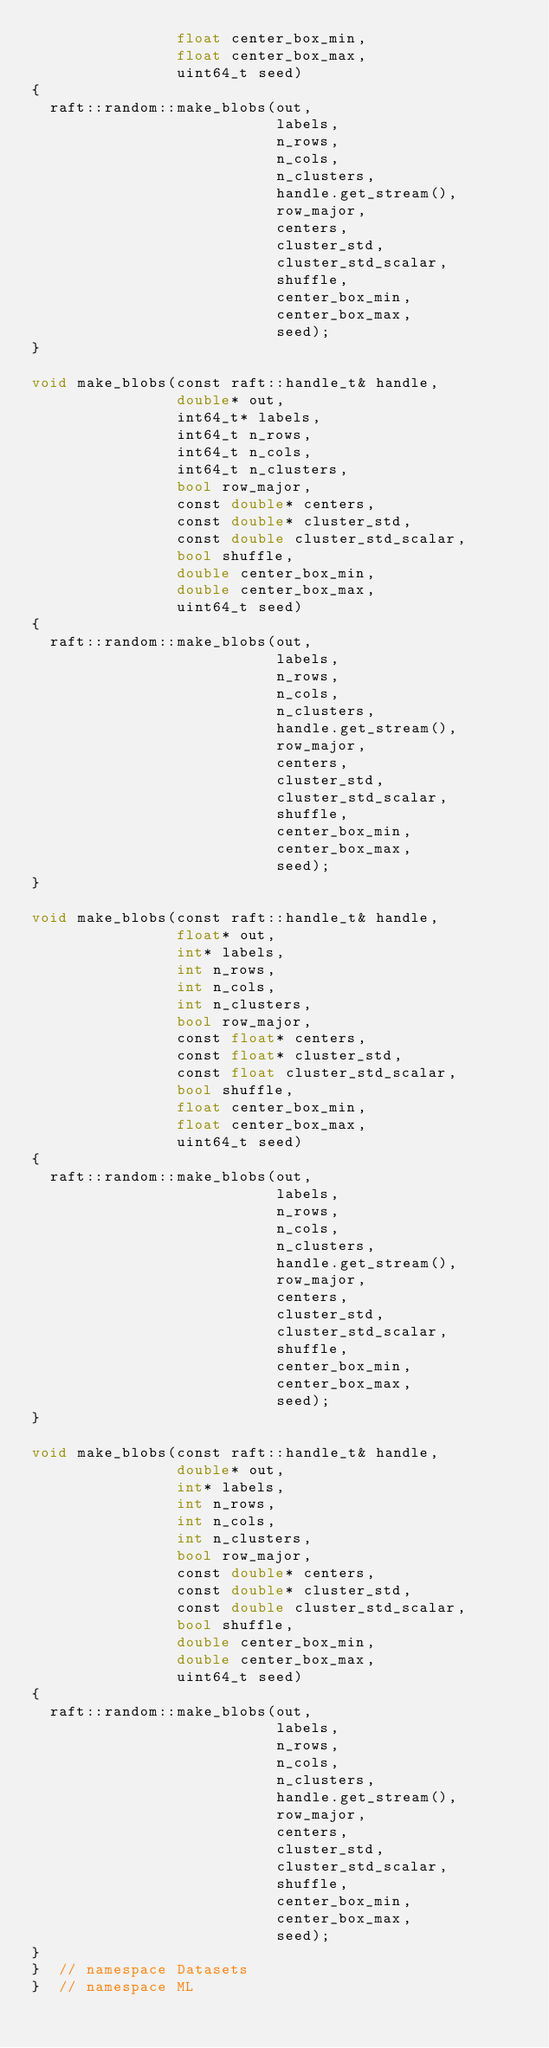<code> <loc_0><loc_0><loc_500><loc_500><_Cuda_>                float center_box_min,
                float center_box_max,
                uint64_t seed)
{
  raft::random::make_blobs(out,
                           labels,
                           n_rows,
                           n_cols,
                           n_clusters,
                           handle.get_stream(),
                           row_major,
                           centers,
                           cluster_std,
                           cluster_std_scalar,
                           shuffle,
                           center_box_min,
                           center_box_max,
                           seed);
}

void make_blobs(const raft::handle_t& handle,
                double* out,
                int64_t* labels,
                int64_t n_rows,
                int64_t n_cols,
                int64_t n_clusters,
                bool row_major,
                const double* centers,
                const double* cluster_std,
                const double cluster_std_scalar,
                bool shuffle,
                double center_box_min,
                double center_box_max,
                uint64_t seed)
{
  raft::random::make_blobs(out,
                           labels,
                           n_rows,
                           n_cols,
                           n_clusters,
                           handle.get_stream(),
                           row_major,
                           centers,
                           cluster_std,
                           cluster_std_scalar,
                           shuffle,
                           center_box_min,
                           center_box_max,
                           seed);
}

void make_blobs(const raft::handle_t& handle,
                float* out,
                int* labels,
                int n_rows,
                int n_cols,
                int n_clusters,
                bool row_major,
                const float* centers,
                const float* cluster_std,
                const float cluster_std_scalar,
                bool shuffle,
                float center_box_min,
                float center_box_max,
                uint64_t seed)
{
  raft::random::make_blobs(out,
                           labels,
                           n_rows,
                           n_cols,
                           n_clusters,
                           handle.get_stream(),
                           row_major,
                           centers,
                           cluster_std,
                           cluster_std_scalar,
                           shuffle,
                           center_box_min,
                           center_box_max,
                           seed);
}

void make_blobs(const raft::handle_t& handle,
                double* out,
                int* labels,
                int n_rows,
                int n_cols,
                int n_clusters,
                bool row_major,
                const double* centers,
                const double* cluster_std,
                const double cluster_std_scalar,
                bool shuffle,
                double center_box_min,
                double center_box_max,
                uint64_t seed)
{
  raft::random::make_blobs(out,
                           labels,
                           n_rows,
                           n_cols,
                           n_clusters,
                           handle.get_stream(),
                           row_major,
                           centers,
                           cluster_std,
                           cluster_std_scalar,
                           shuffle,
                           center_box_min,
                           center_box_max,
                           seed);
}
}  // namespace Datasets
}  // namespace ML
</code> 